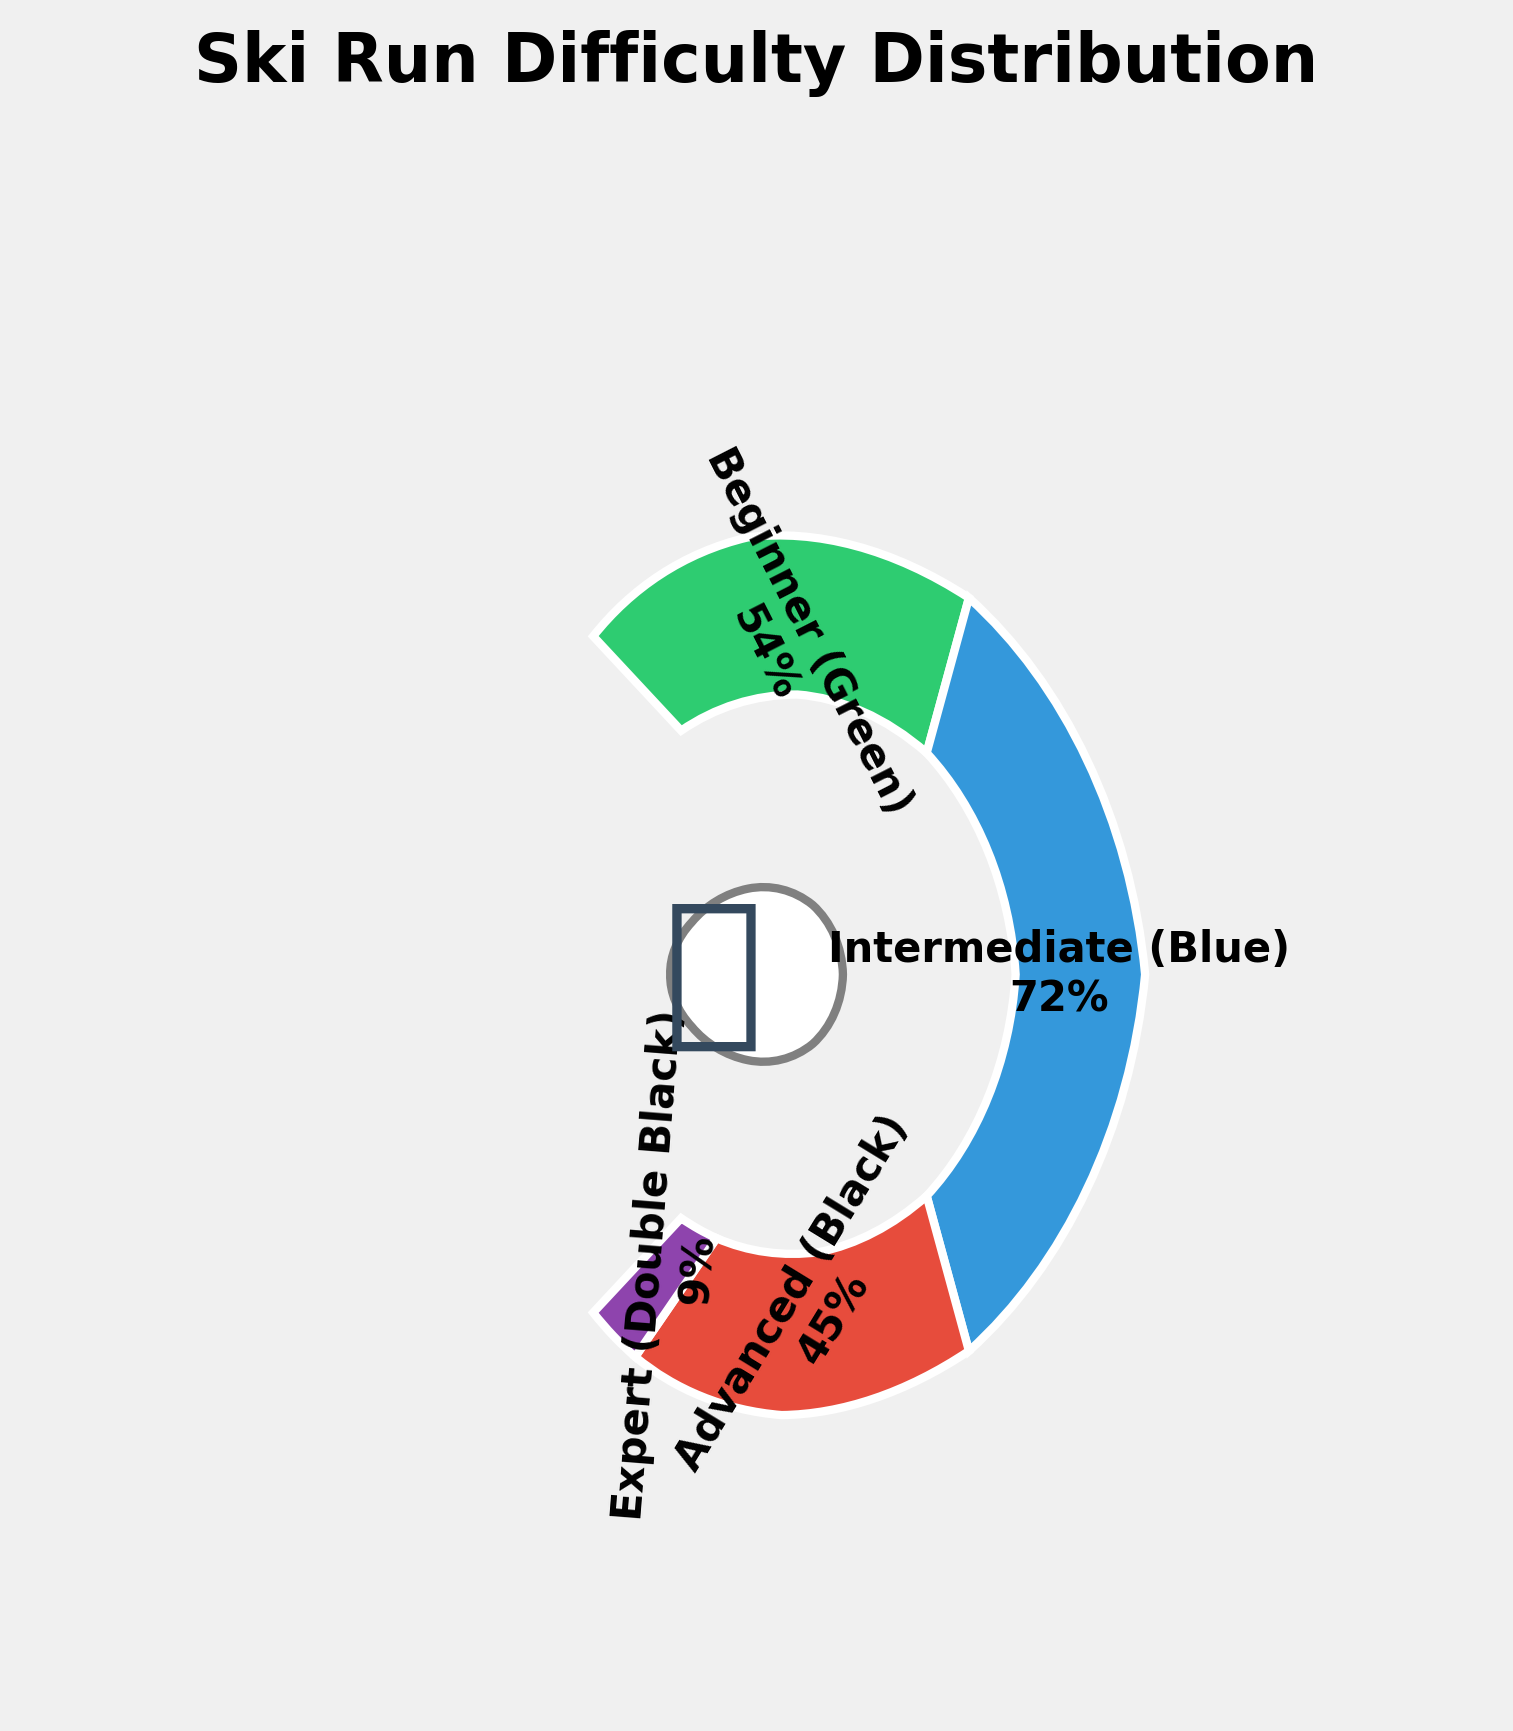How many difficulty levels are shown in the chart? The chart shows four difficulty levels: Beginner (Green), Intermediate (Blue), Advanced (Black), and Expert (Double Black).
Answer: Four Which difficulty level has the highest percentage of ski runs? The chart indicates that Intermediate (Blue) ski runs have the highest percentage, with 40% of the total runs.
Answer: Intermediate (Blue) What is the sum of the percentages for Advanced (Black) and Expert (Double Black) difficulty levels? The Advanced (Black) runs have 25% and the Expert (Double Black) runs have 5%. Summing these gives 25% + 5% = 30%.
Answer: 30% Which difficulty level has the smallest proportion of ski runs? Based on the chart, the Expert (Double Black) difficulty level has the smallest proportion, with only 5% of the ski runs.
Answer: Expert (Double Black) By how much does the percentage of Intermediate (Blue) runs exceed the percentage of Beginner (Green) runs? The Intermediate (Blue) runs have 40% and the Beginner (Green) runs have 30%. The difference is 40% - 30% = 10%.
Answer: 10% If a new difficulty category "Novice" is introduced with 10% runs, what would the combined percentage of Beginner and Novice runs be? The Beginner (Green) runs have 30%, and adding a Novice category with 10% would result in a combined percentage of 30% + 10% = 40%.
Answer: 40% What percentage of ski runs are either Advanced (Black) or Intermediate (Blue)? The Intermediate (Blue) runs account for 40%, and the Advanced (Black) runs account for 25%. Adding these, we get 40% + 25% = 65%.
Answer: 65% How many times greater is the percentage of Intermediate (Blue) runs compared to Expert (Double Black) runs? The Intermediate (Blue) runs make up 40%, while the Expert (Double Black) runs comprise 5%. Dividing these percentages 40% / 5% = 8 times.,
Answer: 8 What is the primary color associated with the Advanced (Black) difficulty level in the chart? The primary color used for Advanced (Black) difficulty level in the chart is a shade of red.
Answer: Red Is the percentage of Advanced (Black) runs more than or equal to the combined percentages of Beginner (Green) and Expert (Double Black) runs? The percentage for Advanced (Black) is 25%. The combined percentage of Beginner (Green) (30%) and Expert (Double Black) (5%) is 30% + 5% = 35%. Since 25% < 35%, the Advanced (Black) runs are less.
Answer: Less 